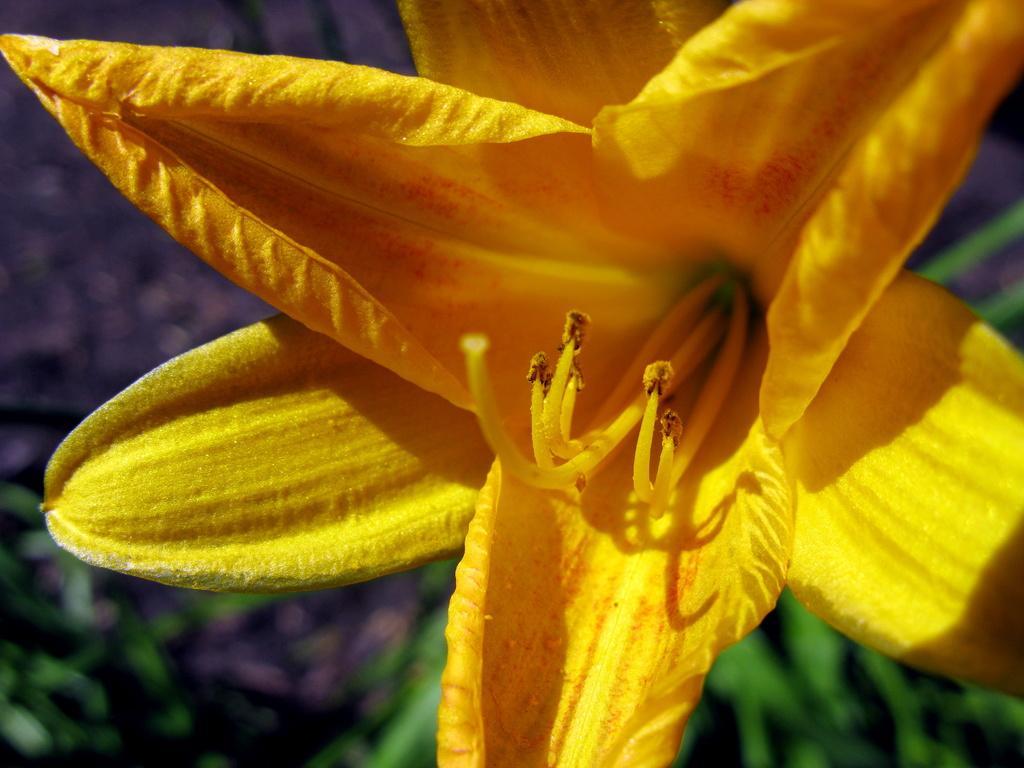Please provide a concise description of this image. In the image I can see a flower which is in yellow color. 